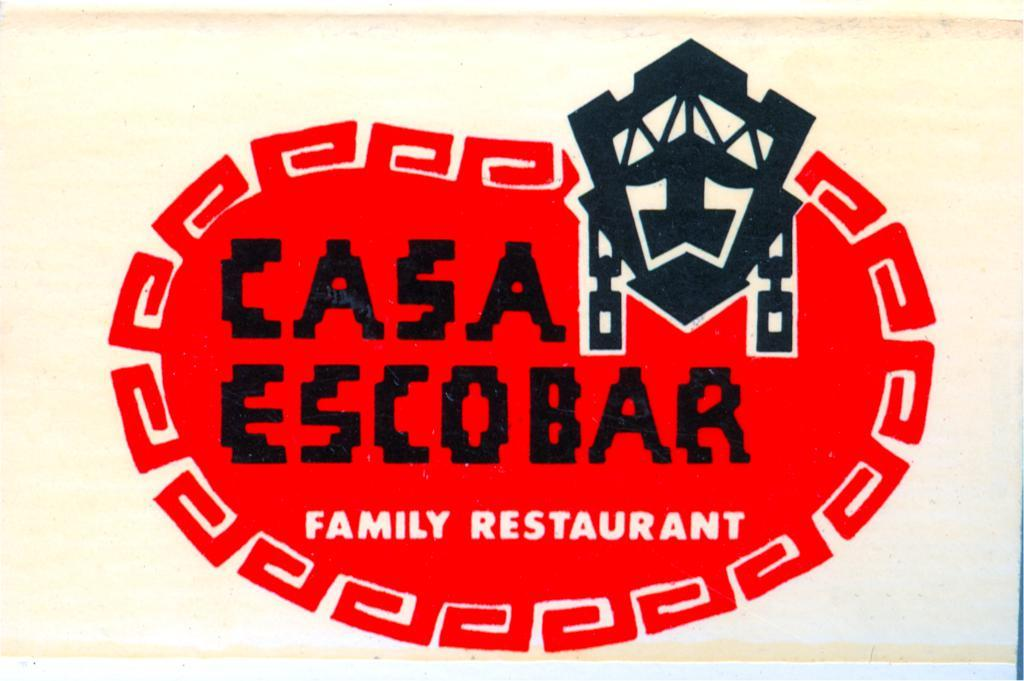Provide a one-sentence caption for the provided image. A sign in white with a red logo of the Casa Escobar Family Restaurant. 